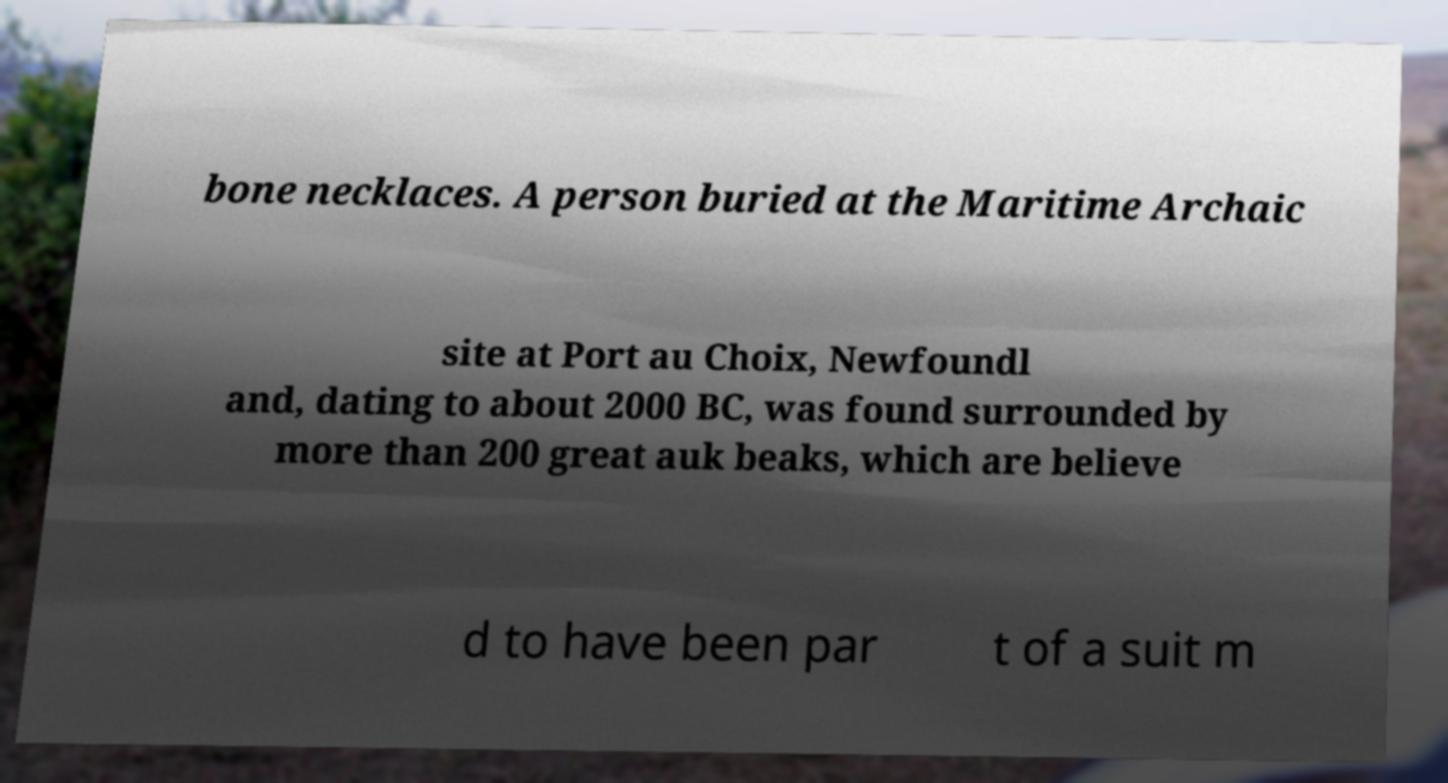Can you accurately transcribe the text from the provided image for me? bone necklaces. A person buried at the Maritime Archaic site at Port au Choix, Newfoundl and, dating to about 2000 BC, was found surrounded by more than 200 great auk beaks, which are believe d to have been par t of a suit m 